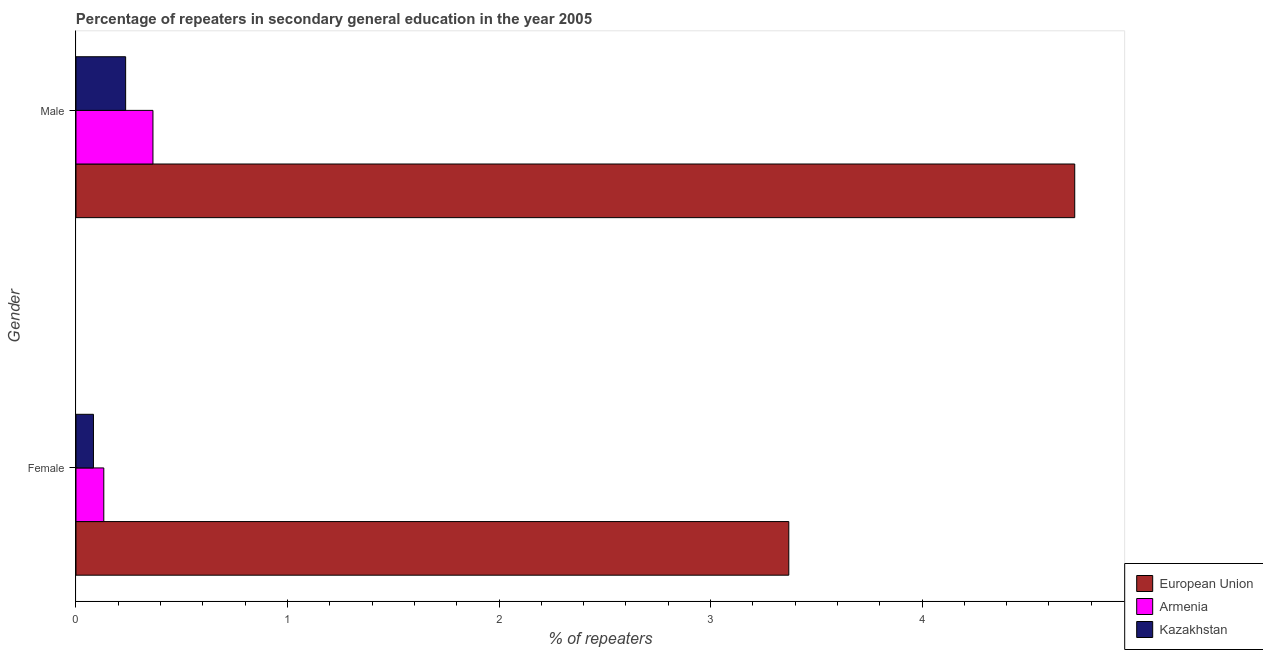Are the number of bars per tick equal to the number of legend labels?
Your answer should be compact. Yes. Are the number of bars on each tick of the Y-axis equal?
Your answer should be compact. Yes. How many bars are there on the 2nd tick from the bottom?
Offer a very short reply. 3. What is the percentage of female repeaters in Kazakhstan?
Your answer should be compact. 0.08. Across all countries, what is the maximum percentage of male repeaters?
Ensure brevity in your answer.  4.72. Across all countries, what is the minimum percentage of female repeaters?
Provide a succinct answer. 0.08. In which country was the percentage of female repeaters minimum?
Ensure brevity in your answer.  Kazakhstan. What is the total percentage of male repeaters in the graph?
Make the answer very short. 5.32. What is the difference between the percentage of male repeaters in Kazakhstan and that in Armenia?
Provide a succinct answer. -0.13. What is the difference between the percentage of female repeaters in European Union and the percentage of male repeaters in Kazakhstan?
Make the answer very short. 3.14. What is the average percentage of female repeaters per country?
Provide a succinct answer. 1.19. What is the difference between the percentage of male repeaters and percentage of female repeaters in Kazakhstan?
Provide a succinct answer. 0.15. In how many countries, is the percentage of female repeaters greater than 2.4 %?
Make the answer very short. 1. What is the ratio of the percentage of male repeaters in European Union to that in Armenia?
Provide a short and direct response. 12.98. In how many countries, is the percentage of female repeaters greater than the average percentage of female repeaters taken over all countries?
Provide a short and direct response. 1. What does the 3rd bar from the top in Female represents?
Provide a short and direct response. European Union. What does the 1st bar from the bottom in Male represents?
Ensure brevity in your answer.  European Union. Are the values on the major ticks of X-axis written in scientific E-notation?
Your answer should be very brief. No. Does the graph contain any zero values?
Your answer should be compact. No. Where does the legend appear in the graph?
Make the answer very short. Bottom right. How are the legend labels stacked?
Offer a very short reply. Vertical. What is the title of the graph?
Your answer should be compact. Percentage of repeaters in secondary general education in the year 2005. Does "European Union" appear as one of the legend labels in the graph?
Your response must be concise. Yes. What is the label or title of the X-axis?
Ensure brevity in your answer.  % of repeaters. What is the label or title of the Y-axis?
Offer a very short reply. Gender. What is the % of repeaters in European Union in Female?
Offer a terse response. 3.37. What is the % of repeaters in Armenia in Female?
Offer a terse response. 0.13. What is the % of repeaters in Kazakhstan in Female?
Ensure brevity in your answer.  0.08. What is the % of repeaters in European Union in Male?
Keep it short and to the point. 4.72. What is the % of repeaters in Armenia in Male?
Offer a terse response. 0.36. What is the % of repeaters in Kazakhstan in Male?
Provide a succinct answer. 0.23. Across all Gender, what is the maximum % of repeaters in European Union?
Provide a short and direct response. 4.72. Across all Gender, what is the maximum % of repeaters in Armenia?
Keep it short and to the point. 0.36. Across all Gender, what is the maximum % of repeaters in Kazakhstan?
Your answer should be compact. 0.23. Across all Gender, what is the minimum % of repeaters of European Union?
Make the answer very short. 3.37. Across all Gender, what is the minimum % of repeaters of Armenia?
Make the answer very short. 0.13. Across all Gender, what is the minimum % of repeaters of Kazakhstan?
Provide a short and direct response. 0.08. What is the total % of repeaters in European Union in the graph?
Offer a very short reply. 8.09. What is the total % of repeaters of Armenia in the graph?
Offer a terse response. 0.5. What is the total % of repeaters in Kazakhstan in the graph?
Provide a succinct answer. 0.32. What is the difference between the % of repeaters of European Union in Female and that in Male?
Your answer should be compact. -1.35. What is the difference between the % of repeaters in Armenia in Female and that in Male?
Make the answer very short. -0.23. What is the difference between the % of repeaters of Kazakhstan in Female and that in Male?
Your answer should be very brief. -0.15. What is the difference between the % of repeaters in European Union in Female and the % of repeaters in Armenia in Male?
Your response must be concise. 3.01. What is the difference between the % of repeaters of European Union in Female and the % of repeaters of Kazakhstan in Male?
Your answer should be very brief. 3.14. What is the difference between the % of repeaters of Armenia in Female and the % of repeaters of Kazakhstan in Male?
Your answer should be compact. -0.1. What is the average % of repeaters of European Union per Gender?
Your answer should be compact. 4.05. What is the average % of repeaters of Armenia per Gender?
Make the answer very short. 0.25. What is the average % of repeaters of Kazakhstan per Gender?
Your answer should be compact. 0.16. What is the difference between the % of repeaters in European Union and % of repeaters in Armenia in Female?
Ensure brevity in your answer.  3.24. What is the difference between the % of repeaters of European Union and % of repeaters of Kazakhstan in Female?
Offer a terse response. 3.29. What is the difference between the % of repeaters in Armenia and % of repeaters in Kazakhstan in Female?
Make the answer very short. 0.05. What is the difference between the % of repeaters of European Union and % of repeaters of Armenia in Male?
Provide a short and direct response. 4.36. What is the difference between the % of repeaters of European Union and % of repeaters of Kazakhstan in Male?
Offer a terse response. 4.49. What is the difference between the % of repeaters of Armenia and % of repeaters of Kazakhstan in Male?
Provide a short and direct response. 0.13. What is the ratio of the % of repeaters of European Union in Female to that in Male?
Offer a terse response. 0.71. What is the ratio of the % of repeaters of Armenia in Female to that in Male?
Your answer should be compact. 0.36. What is the ratio of the % of repeaters of Kazakhstan in Female to that in Male?
Keep it short and to the point. 0.35. What is the difference between the highest and the second highest % of repeaters in European Union?
Your response must be concise. 1.35. What is the difference between the highest and the second highest % of repeaters in Armenia?
Offer a very short reply. 0.23. What is the difference between the highest and the second highest % of repeaters in Kazakhstan?
Your response must be concise. 0.15. What is the difference between the highest and the lowest % of repeaters of European Union?
Your response must be concise. 1.35. What is the difference between the highest and the lowest % of repeaters in Armenia?
Offer a terse response. 0.23. What is the difference between the highest and the lowest % of repeaters of Kazakhstan?
Your answer should be very brief. 0.15. 